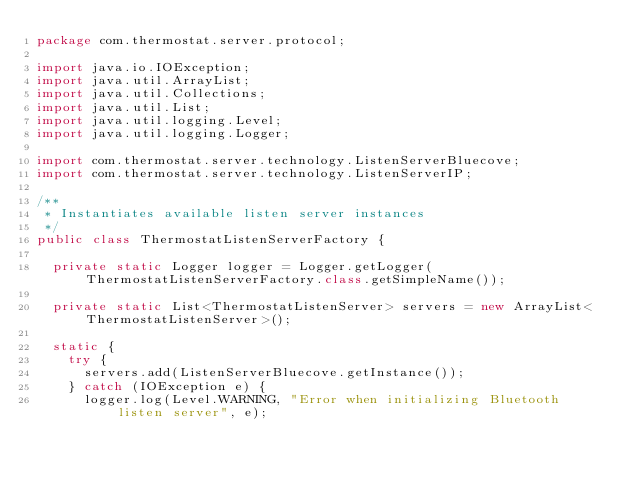Convert code to text. <code><loc_0><loc_0><loc_500><loc_500><_Java_>package com.thermostat.server.protocol;

import java.io.IOException;
import java.util.ArrayList;
import java.util.Collections;
import java.util.List;
import java.util.logging.Level;
import java.util.logging.Logger;

import com.thermostat.server.technology.ListenServerBluecove;
import com.thermostat.server.technology.ListenServerIP;

/**
 * Instantiates available listen server instances 
 */
public class ThermostatListenServerFactory {

	private static Logger logger = Logger.getLogger(ThermostatListenServerFactory.class.getSimpleName());

	private static List<ThermostatListenServer> servers = new ArrayList<ThermostatListenServer>();
	
	static {
		try {
			servers.add(ListenServerBluecove.getInstance());
		} catch (IOException e) {
			logger.log(Level.WARNING, "Error when initializing Bluetooth listen server", e);</code> 